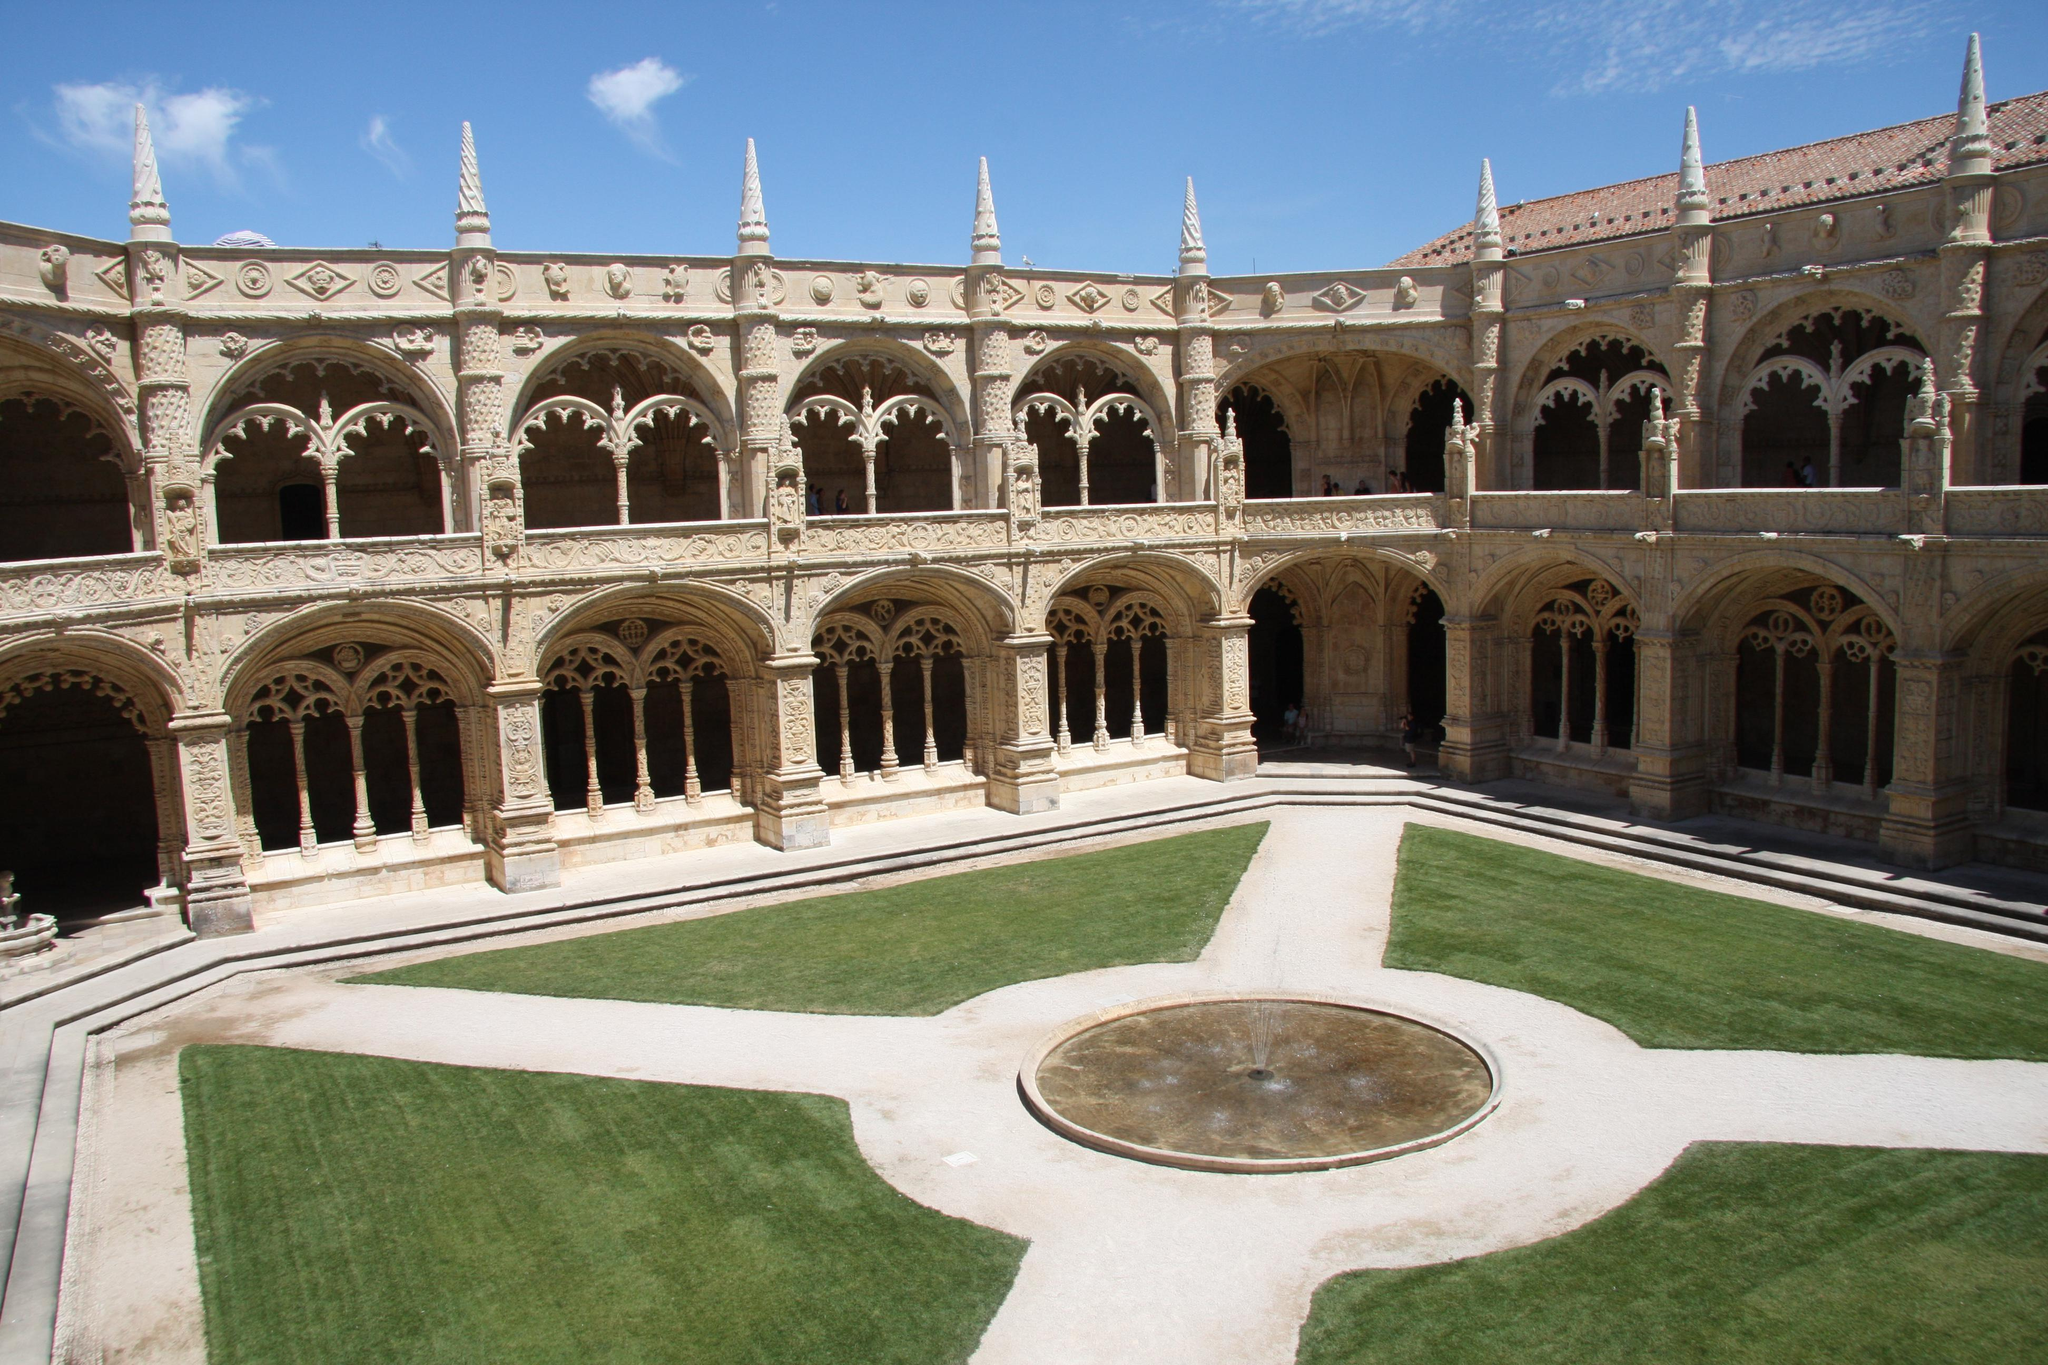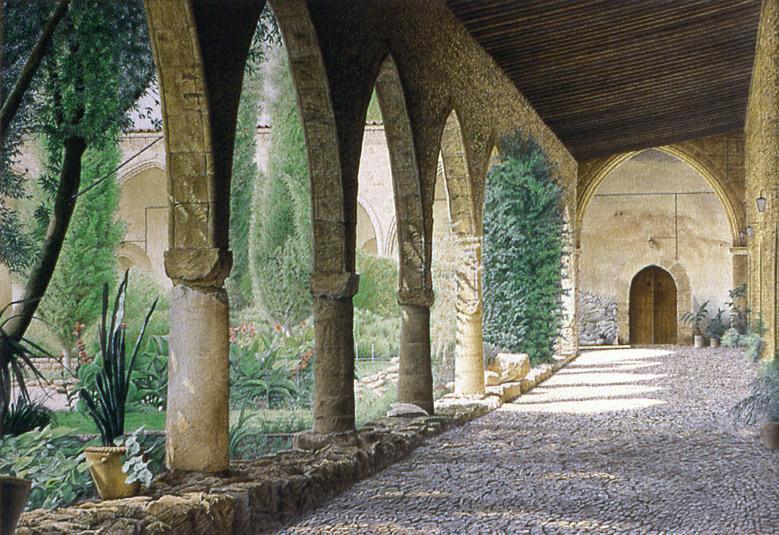The first image is the image on the left, the second image is the image on the right. Evaluate the accuracy of this statement regarding the images: "A single door can be seen at the end of the corridor in one of the images.". Is it true? Answer yes or no. Yes. 